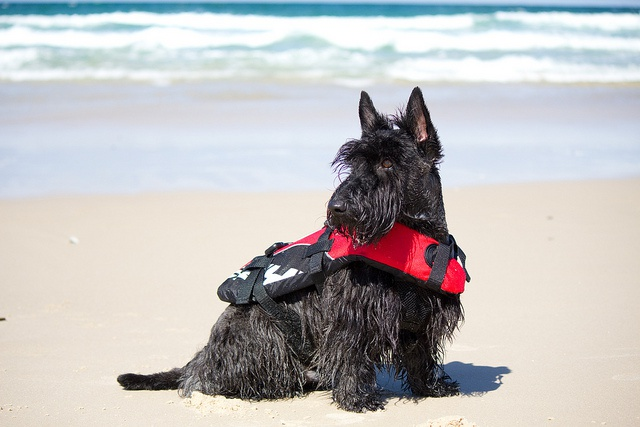Describe the objects in this image and their specific colors. I can see a dog in darkgray, black, and gray tones in this image. 